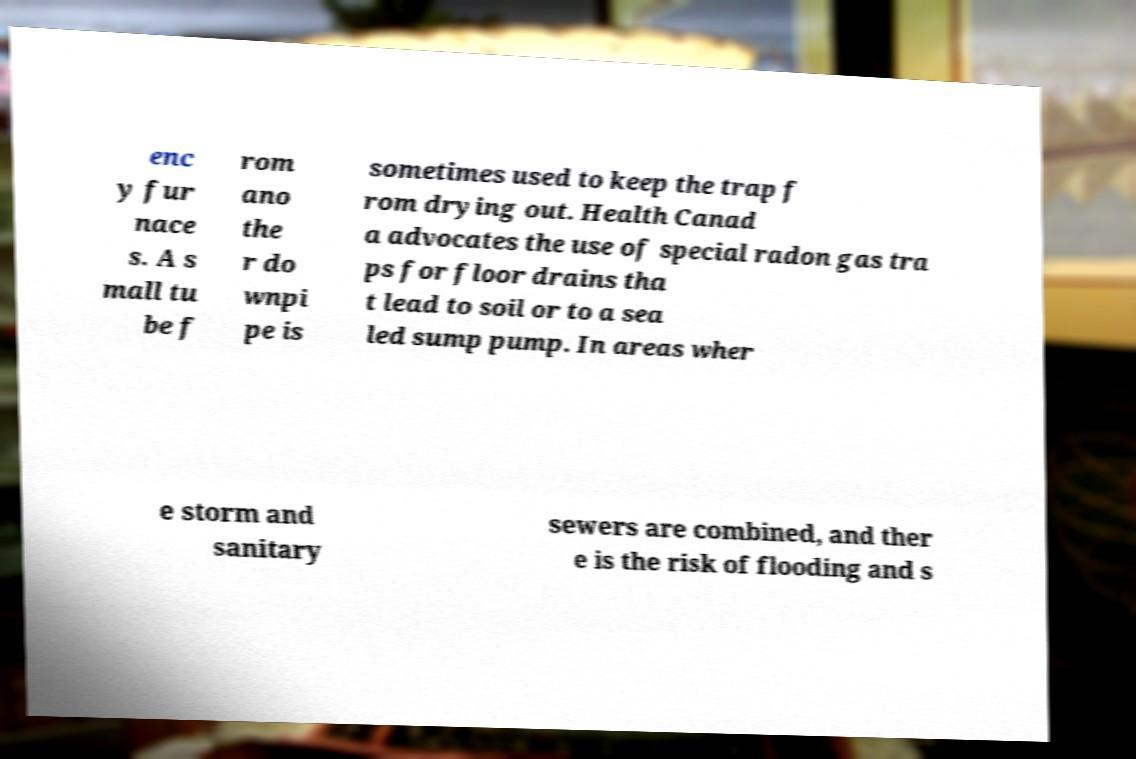Can you accurately transcribe the text from the provided image for me? enc y fur nace s. A s mall tu be f rom ano the r do wnpi pe is sometimes used to keep the trap f rom drying out. Health Canad a advocates the use of special radon gas tra ps for floor drains tha t lead to soil or to a sea led sump pump. In areas wher e storm and sanitary sewers are combined, and ther e is the risk of flooding and s 